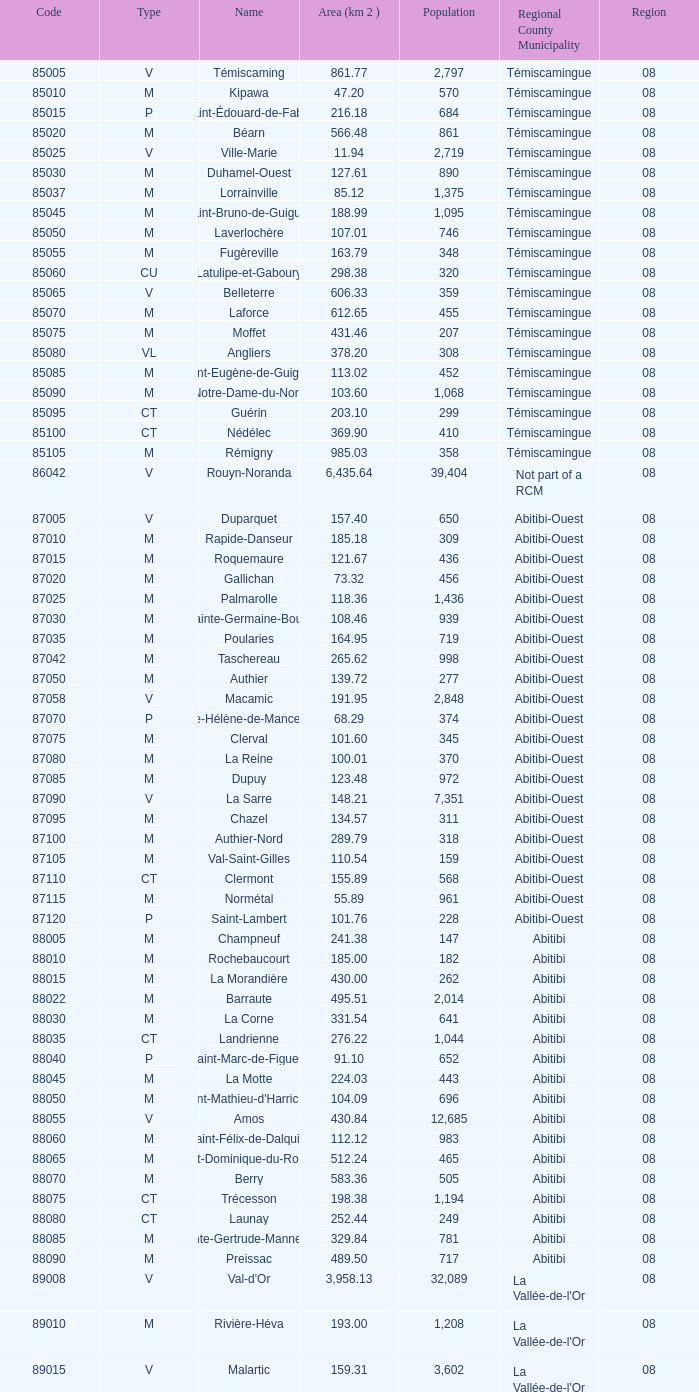What is the smallest area of dupuy in square kilometers? 123.48. 